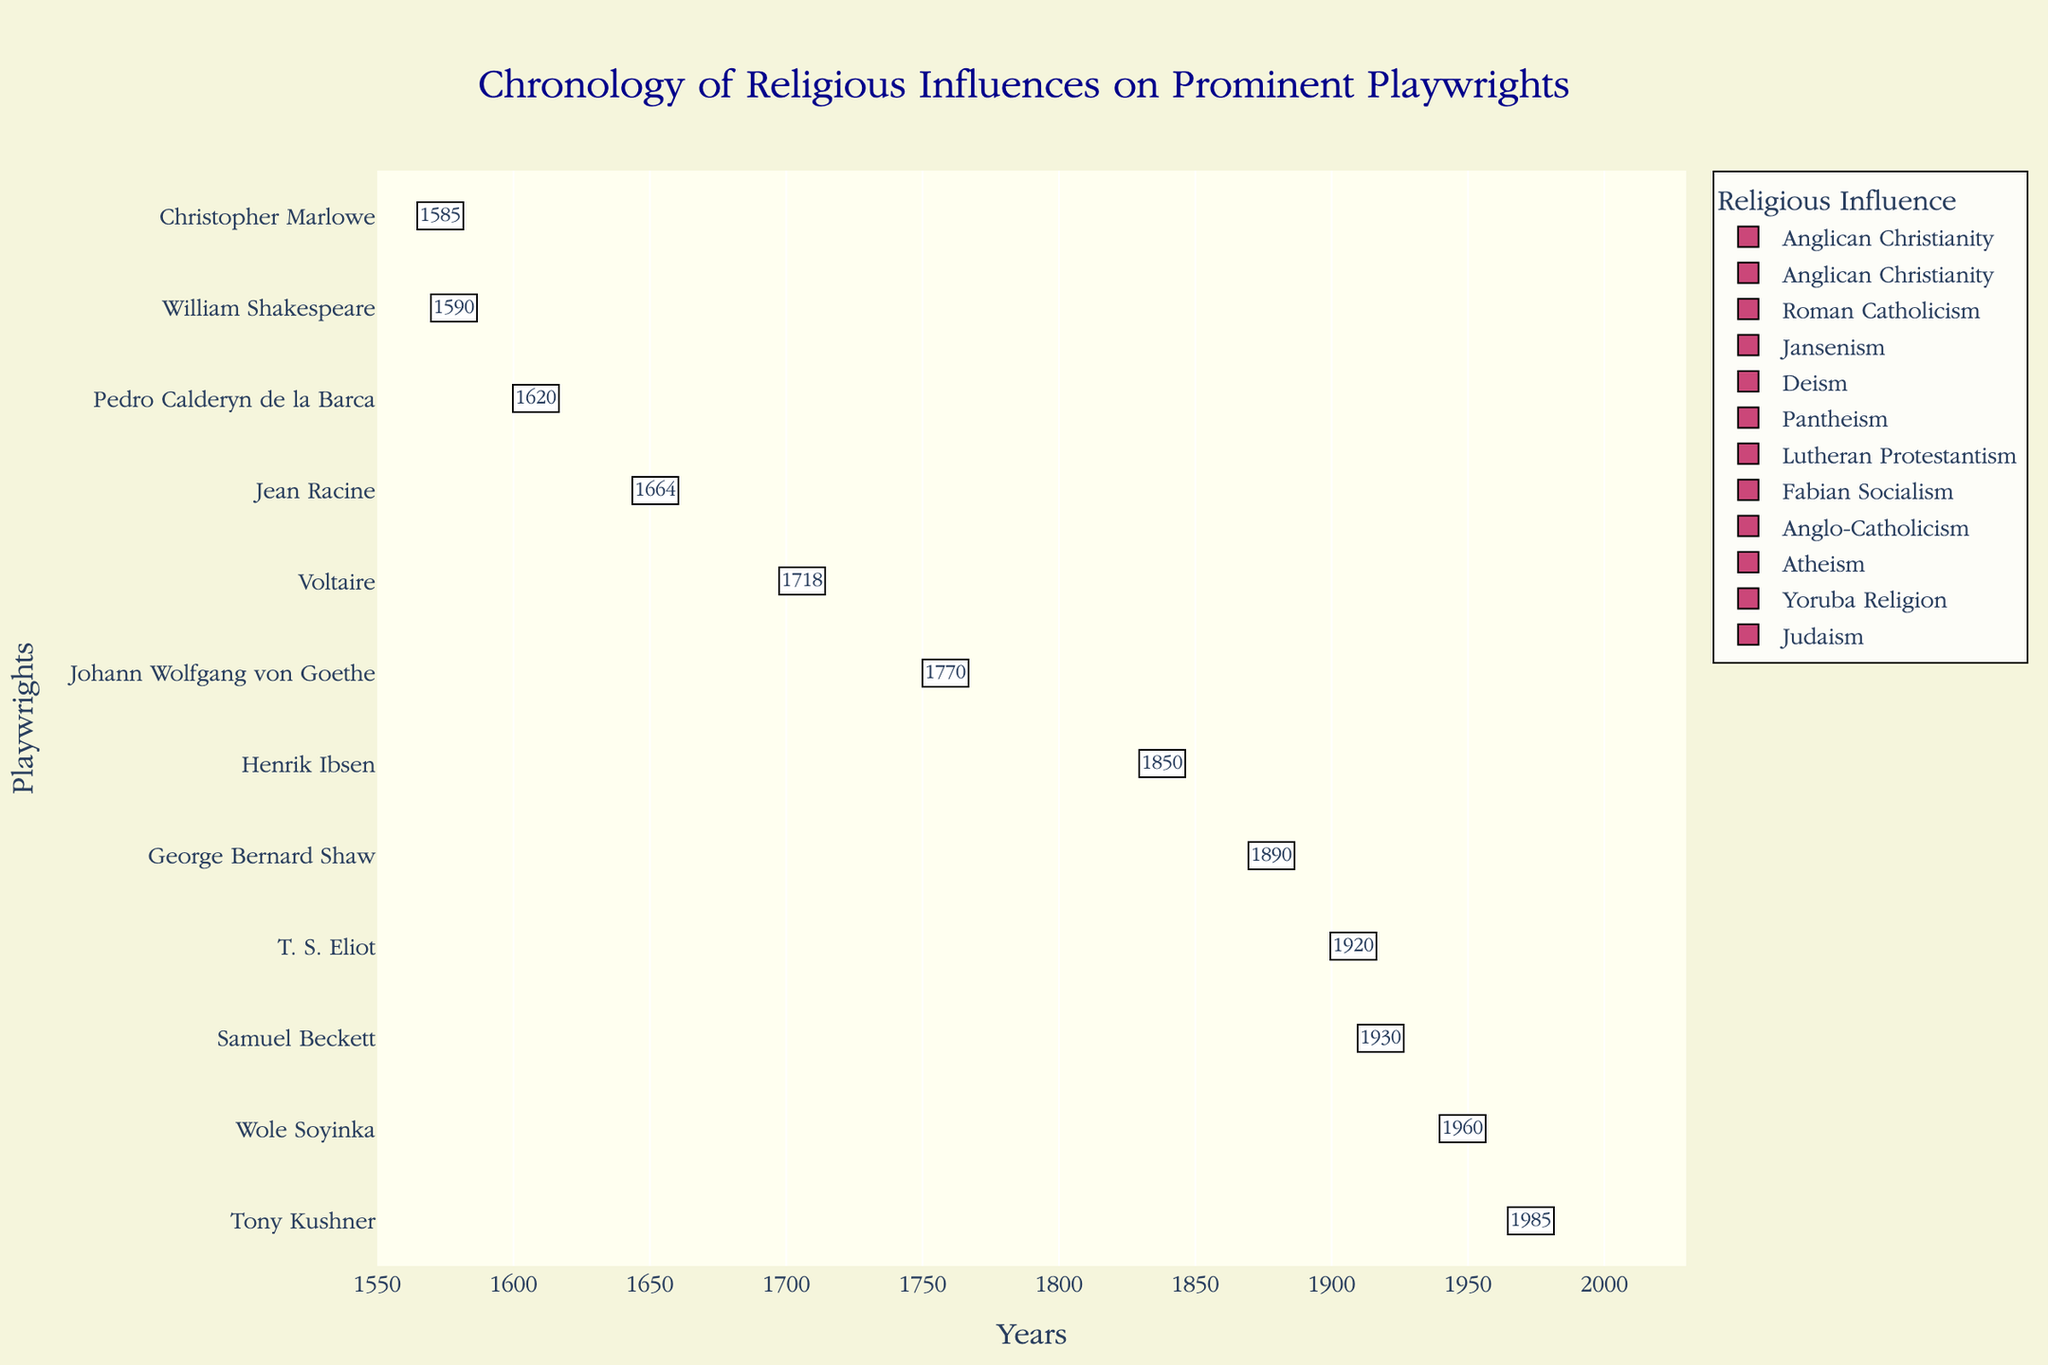Which religious influence has the longest duration for a single playwright? Look at the lengths of each bar, and compare the start and end years for each playwright. The religious influence with the longest span is Christopher Marlowe's Anglican Christianity (1590-1616).
Answer: Anglican Christianity Which playwrights have a start year in the 17th century? Identify the bars starting between 1600 and 1699. The playwrights are Pedro Calderón de la Barca (1620), Jean Racine (1664).
Answer: Pedro Calderón de la Barca and Jean Racine How many different religious influences are represented in the chart? Count the unique religious influences mentioned in the chart. There are 11 unique religious influences shown.
Answer: 11 Which playwright has the shortest duration of religious influence recorded in the chart? Compare the lengths of all the bars. The shortest duration is for Samuel Beckett (1930-1989), spanning 59 years.
Answer: Samuel Beckett Between T. S. Eliot and Samuel Beckett, who was influenced by religion for a longer period? Compare the duration of religious influence for T. S. Eliot (1920-1965) and Samuel Beckett (1930-1989). Eliot's duration is 45 years and Beckett’s is 59 years.
Answer: Samuel Beckett During which century did most of the represented playwrights experience their religious influence? Check the century that spans the most start and end years of the playwrights. Most influences span the 18th century if considering the historical timeline based on the data.
Answer: 18th century How long is the combined influence of Judaism and Yoruba Religion? Add the duration of Tony Kushner (1985-2023) and Wole Soyinka (1960-2023). Kushner's duration is 38 years and Soyinka's is 63 years. Summing these gives 101 combined years.
Answer: 101 years Which two playwrights had overlapping periods of religious influences? Compare the periods for overlaps. For example, Pedro Calderón de la Barca (1620-1681) and Jean Racine (1664-1699) overlap from 1664 to 1681.
Answer: Pedro Calderón de la Barca and Jean Racine 